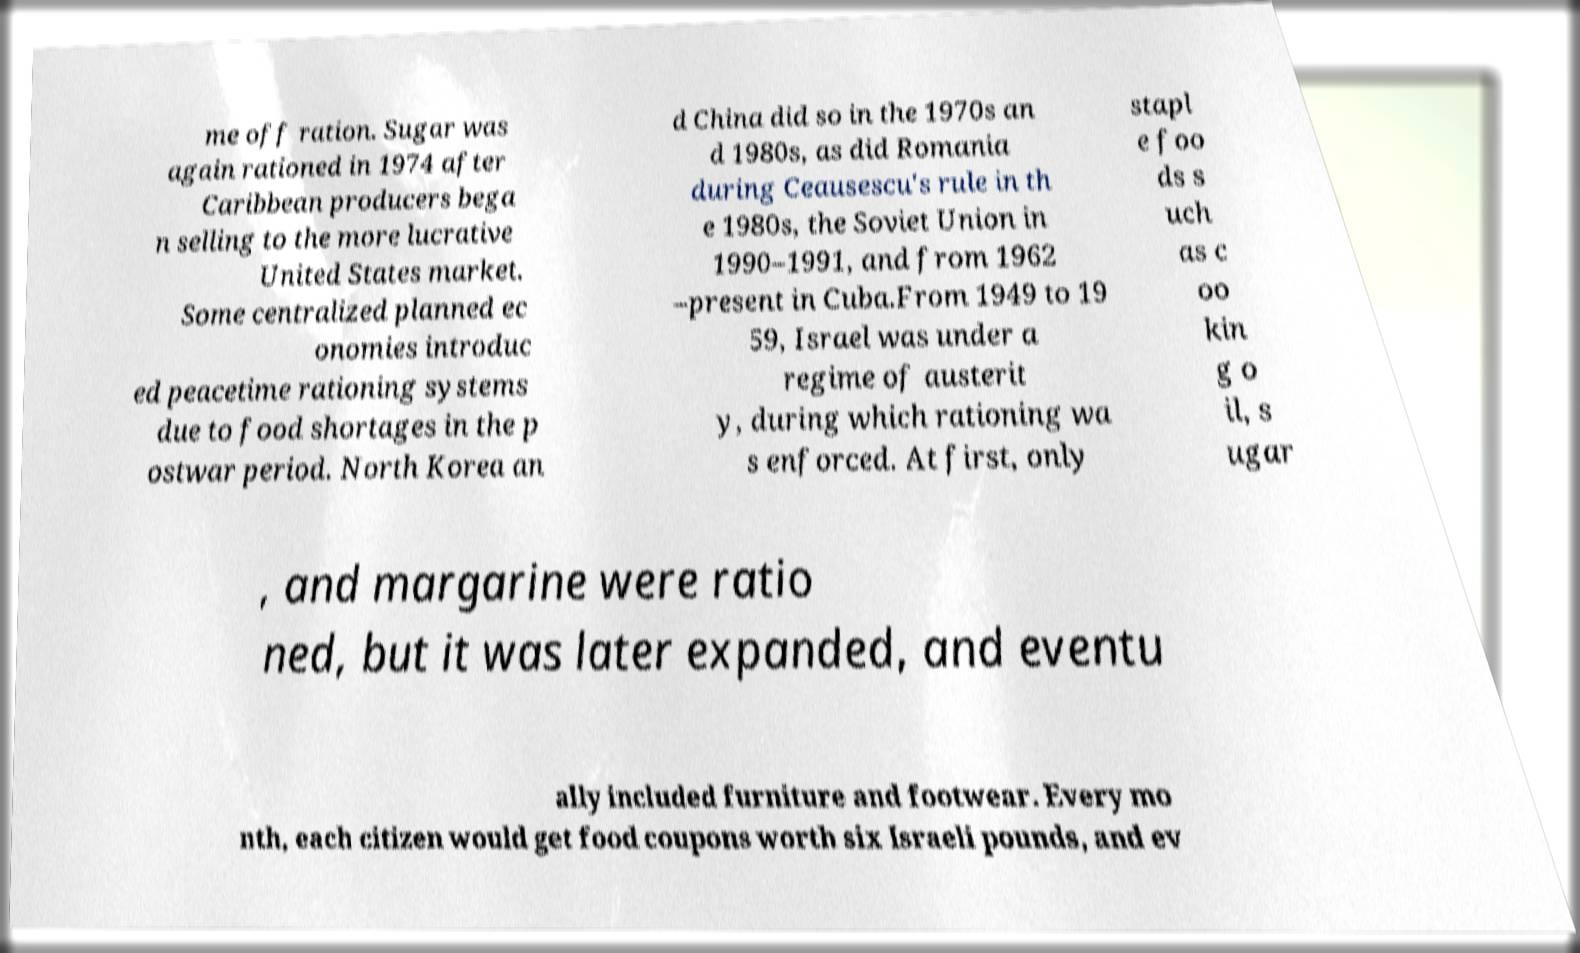There's text embedded in this image that I need extracted. Can you transcribe it verbatim? me off ration. Sugar was again rationed in 1974 after Caribbean producers bega n selling to the more lucrative United States market. Some centralized planned ec onomies introduc ed peacetime rationing systems due to food shortages in the p ostwar period. North Korea an d China did so in the 1970s an d 1980s, as did Romania during Ceausescu's rule in th e 1980s, the Soviet Union in 1990–1991, and from 1962 –present in Cuba.From 1949 to 19 59, Israel was under a regime of austerit y, during which rationing wa s enforced. At first, only stapl e foo ds s uch as c oo kin g o il, s ugar , and margarine were ratio ned, but it was later expanded, and eventu ally included furniture and footwear. Every mo nth, each citizen would get food coupons worth six Israeli pounds, and ev 